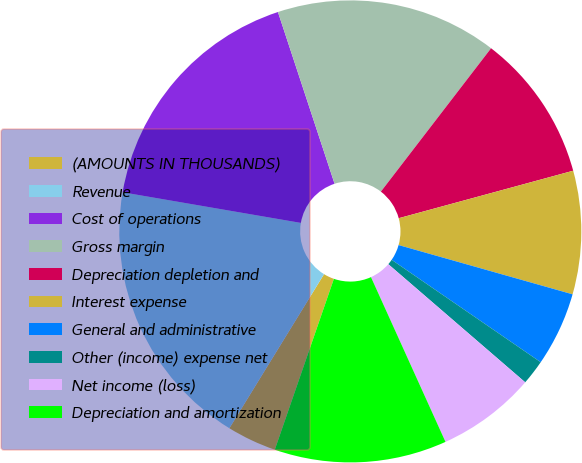Convert chart to OTSL. <chart><loc_0><loc_0><loc_500><loc_500><pie_chart><fcel>(AMOUNTS IN THOUSANDS)<fcel>Revenue<fcel>Cost of operations<fcel>Gross margin<fcel>Depreciation depletion and<fcel>Interest expense<fcel>General and administrative<fcel>Other (income) expense net<fcel>Net income (loss)<fcel>Depreciation and amortization<nl><fcel>3.47%<fcel>18.94%<fcel>17.22%<fcel>15.5%<fcel>10.34%<fcel>8.62%<fcel>5.19%<fcel>1.75%<fcel>6.91%<fcel>12.06%<nl></chart> 